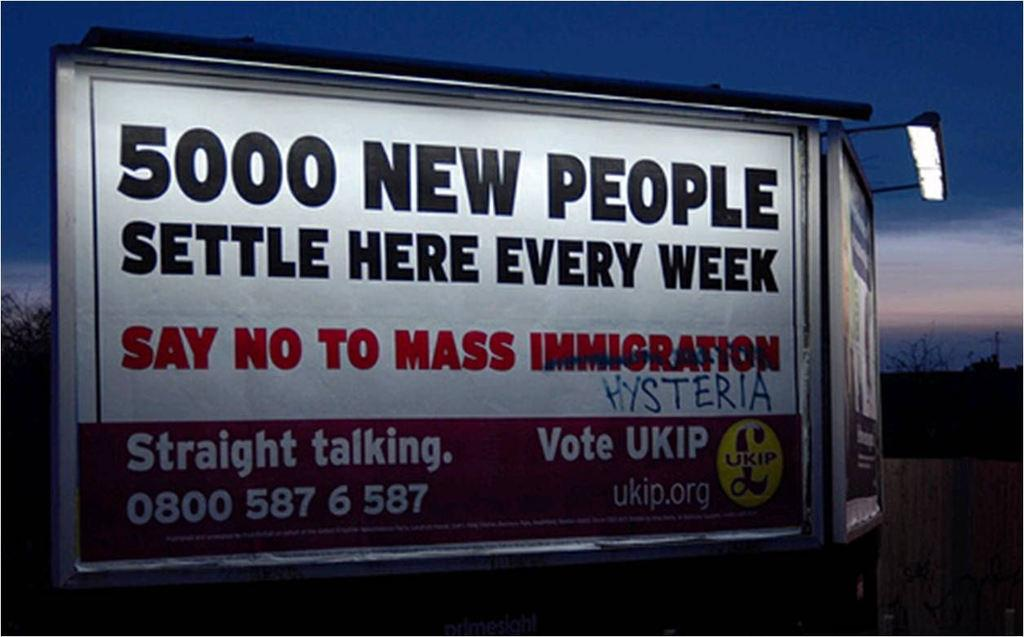What objects are hanging in the image? There are banners in the image. What type of illumination is present in the image? There are lights in the image. What type of vegetation is visible in the image? There are trees in the image. What type of structure is present in the image? There is a wall in the image. What is visible in the background of the image? The sky is visible in the background of the image. What type of grain is being harvested in the image? There is no grain present in the image. How many elbows can be seen in the image? There are no elbows present in the image. What type of tree is visible in the image? The provided facts do not specify the type of tree; only that there are trees in the image. 